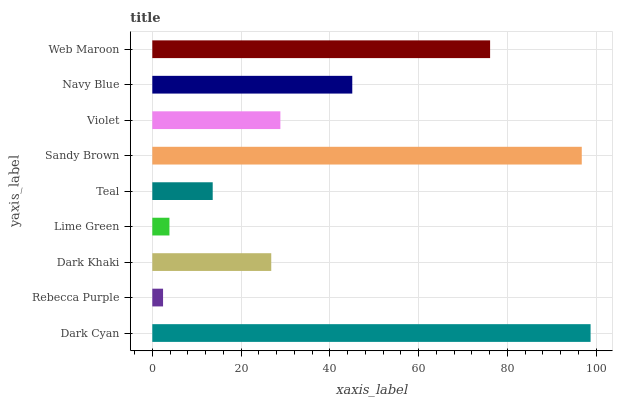Is Rebecca Purple the minimum?
Answer yes or no. Yes. Is Dark Cyan the maximum?
Answer yes or no. Yes. Is Dark Khaki the minimum?
Answer yes or no. No. Is Dark Khaki the maximum?
Answer yes or no. No. Is Dark Khaki greater than Rebecca Purple?
Answer yes or no. Yes. Is Rebecca Purple less than Dark Khaki?
Answer yes or no. Yes. Is Rebecca Purple greater than Dark Khaki?
Answer yes or no. No. Is Dark Khaki less than Rebecca Purple?
Answer yes or no. No. Is Violet the high median?
Answer yes or no. Yes. Is Violet the low median?
Answer yes or no. Yes. Is Rebecca Purple the high median?
Answer yes or no. No. Is Lime Green the low median?
Answer yes or no. No. 